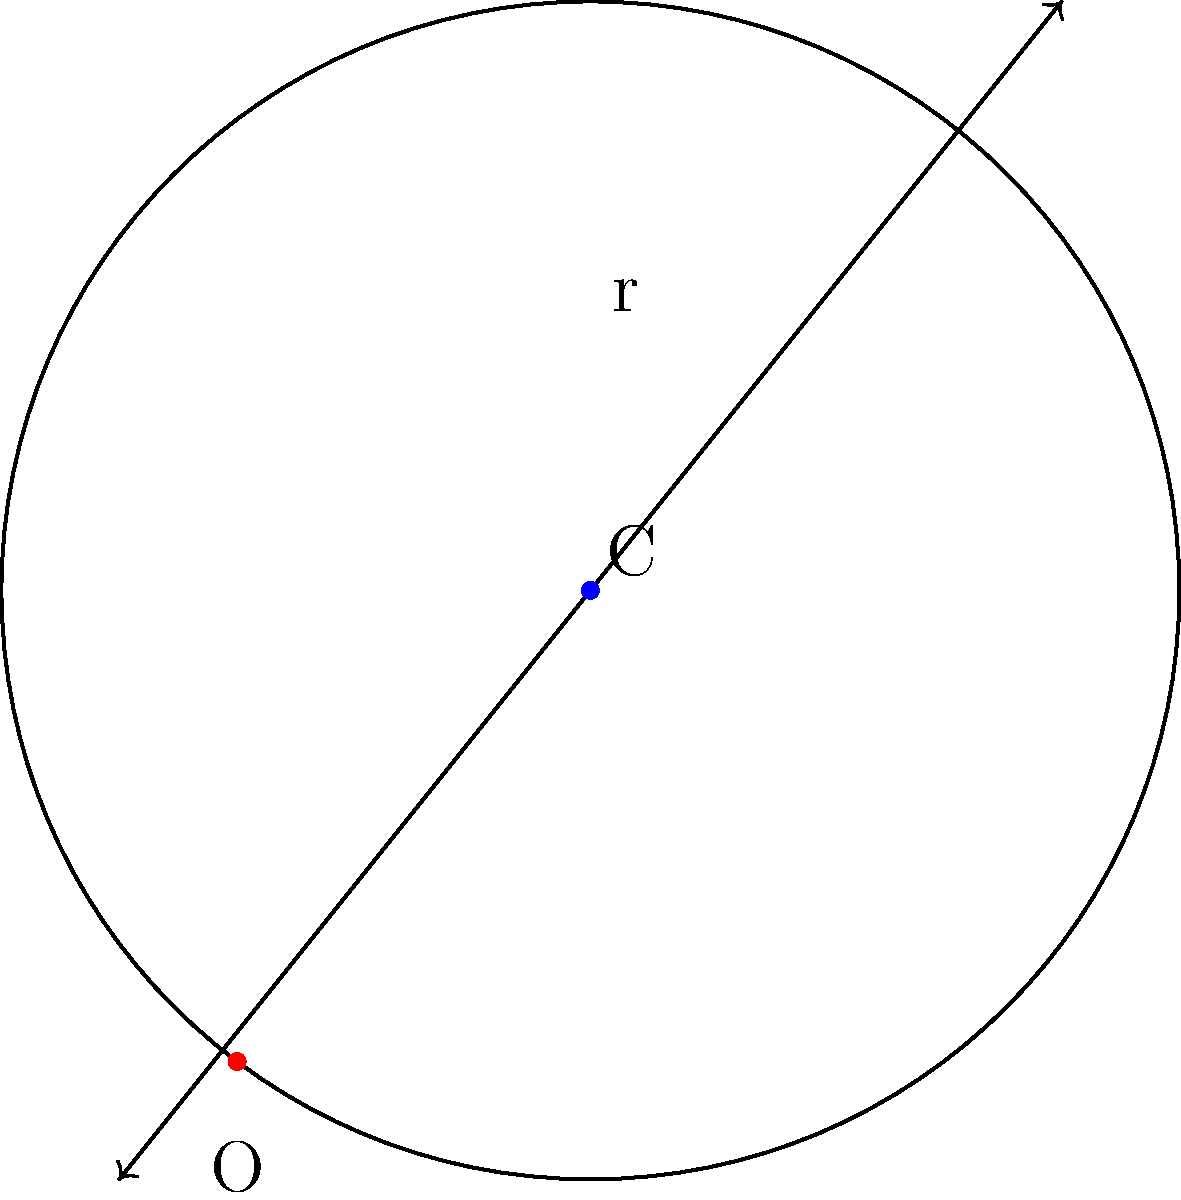In the world of Westeros, the Lannister army has positioned a catapult at point C(3,4) on a coordinate plane. The range of the catapult forms a perfect circle with a radius of 5 units. As a military strategist, you need to determine the equation of this circle to plan your defense. What is the equation of the circle representing the catapult's range? Let's approach this step-by-step:

1) The general equation of a circle is $$(x-h)^2 + (y-k)^2 = r^2$$
   where (h,k) is the center of the circle and r is the radius.

2) In this case:
   - The center (h,k) is at C(3,4)
   - The radius r is 5 units

3) Substituting these values into the general equation:
   $$(x-3)^2 + (y-4)^2 = 5^2$$

4) Simplify the right side:
   $$(x-3)^2 + (y-4)^2 = 25$$

This is the equation of the circle representing the catapult's range.
Answer: $$(x-3)^2 + (y-4)^2 = 25$$ 